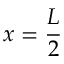Convert formula to latex. <formula><loc_0><loc_0><loc_500><loc_500>x = \frac { L } { 2 }</formula> 